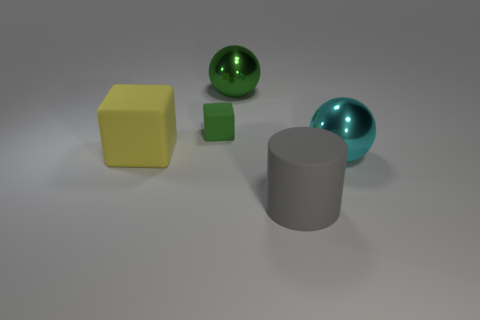There is a cyan shiny thing; are there any small blocks left of it?
Ensure brevity in your answer.  Yes. Are the block left of the tiny green matte block and the block that is to the right of the yellow rubber thing made of the same material?
Ensure brevity in your answer.  Yes. Is the number of small green matte things right of the matte cylinder less than the number of tiny green objects?
Provide a succinct answer. Yes. There is a large object that is behind the small green matte block; what color is it?
Your response must be concise. Green. There is a large ball on the right side of the metal thing that is on the left side of the large cyan object; what is it made of?
Offer a terse response. Metal. Is there a metallic object of the same size as the yellow rubber thing?
Keep it short and to the point. Yes. What number of objects are either shiny balls in front of the small cube or green objects that are on the left side of the large green metallic ball?
Give a very brief answer. 2. There is a ball behind the tiny matte cube; is it the same size as the rubber object that is in front of the large yellow thing?
Ensure brevity in your answer.  Yes. Is there a big gray cylinder right of the large matte object in front of the big yellow object?
Make the answer very short. No. There is a large yellow matte cube; what number of metallic objects are behind it?
Give a very brief answer. 1. 